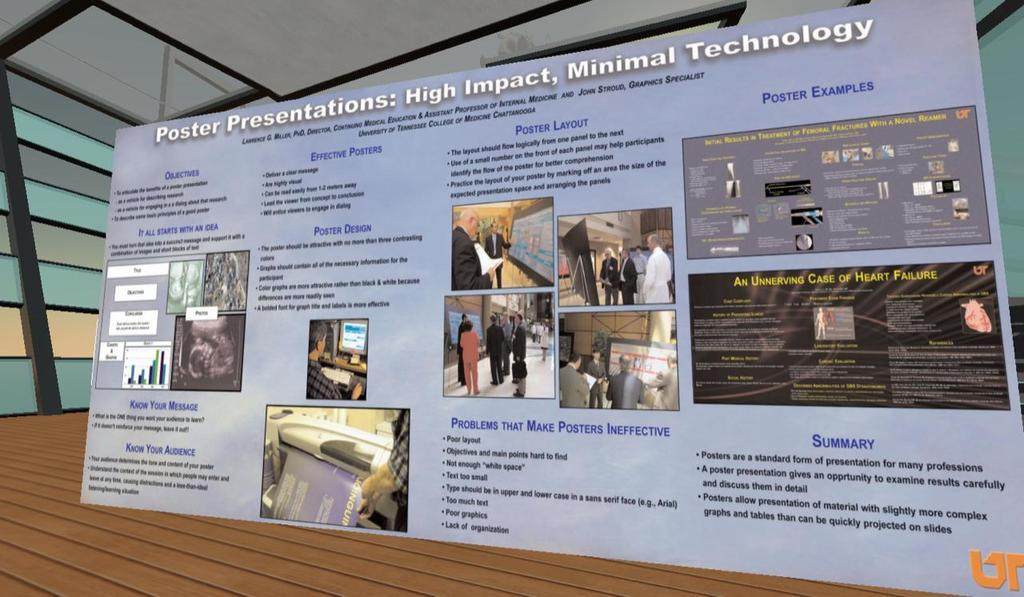What is located in the center of the image? There is a poster in the center of the image. What message does the poster convey? The text on the poster says "poster presentation, high impact; minimal technology." What type of test can be seen on the plate in the image? There is no plate or test present in the image; it only features a poster. 